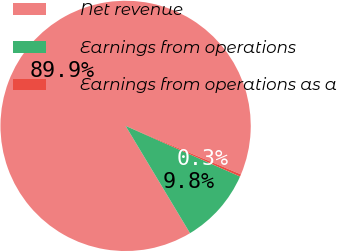Convert chart. <chart><loc_0><loc_0><loc_500><loc_500><pie_chart><fcel>Net revenue<fcel>Earnings from operations<fcel>Earnings from operations as a<nl><fcel>89.94%<fcel>9.76%<fcel>0.3%<nl></chart> 